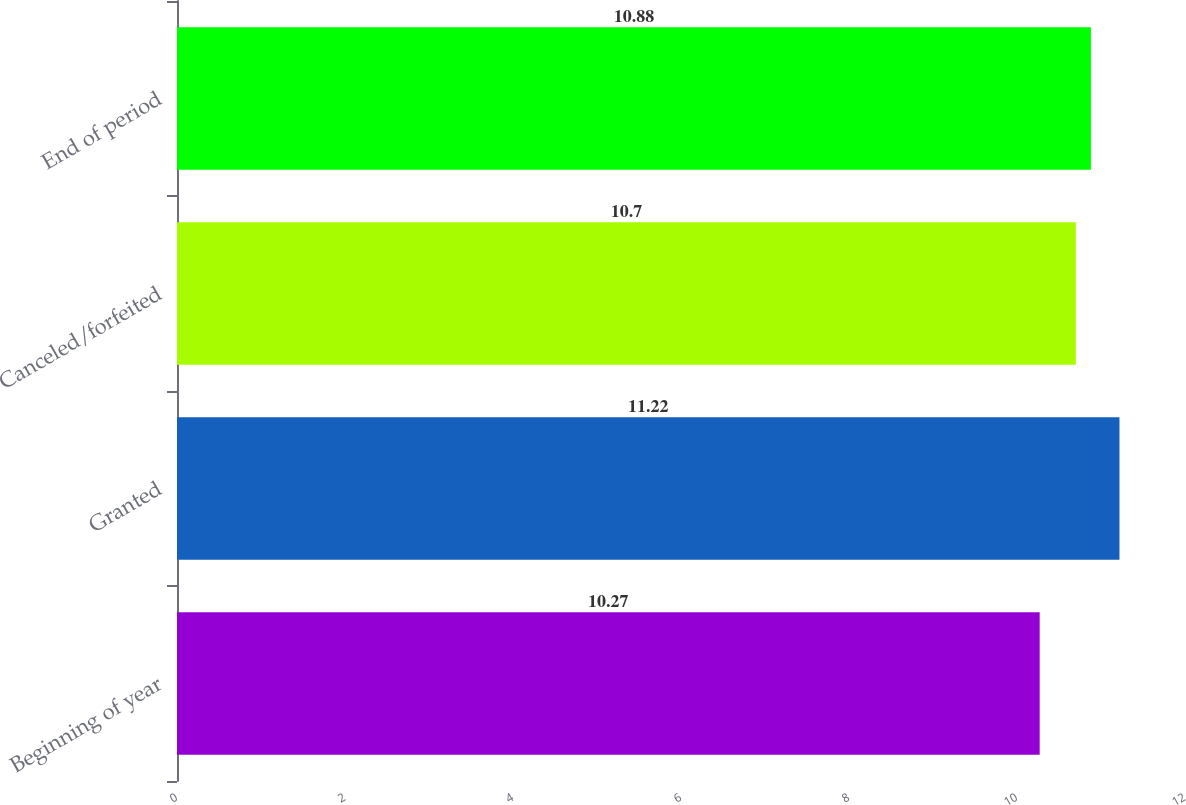<chart> <loc_0><loc_0><loc_500><loc_500><bar_chart><fcel>Beginning of year<fcel>Granted<fcel>Canceled/forfeited<fcel>End of period<nl><fcel>10.27<fcel>11.22<fcel>10.7<fcel>10.88<nl></chart> 